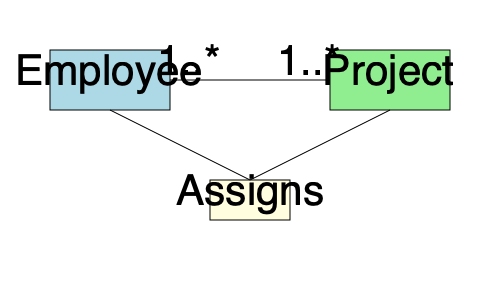Given the entity-relationship diagram above representing employees and projects in a paperless organization management system, what is the most efficient way to implement this many-to-many relationship in a relational database schema to optimize query performance and maintain data integrity? To optimize the database schema design based on the given entity-relationship diagram, we need to follow these steps:

1. Identify the entities: We have two main entities - Employee and Project.

2. Recognize the relationship: There is a many-to-many relationship between Employee and Project, represented by the "Assigns" relationship.

3. Create tables for entities:
   - Create an "Employees" table with a primary key (e.g., EmployeeID).
   - Create a "Projects" table with a primary key (e.g., ProjectID).

4. Handle the many-to-many relationship:
   - Create a junction table, often called "Assignments" or "EmployeeProjects".
   - This table should have two foreign keys: EmployeeID and ProjectID.
   - The combination of these two foreign keys should form the primary key of the junction table.

5. Optimize for query performance:
   - Add indexes on the foreign key columns in the junction table.
   - Consider adding additional columns to the junction table if needed (e.g., AssignmentDate, Role).

6. Maintain data integrity:
   - Implement referential integrity constraints on the foreign keys in the junction table.
   - Use ON DELETE and ON UPDATE actions (e.g., CASCADE, RESTRICT) as appropriate for the business rules.

The most efficient implementation is to create three tables: Employees, Projects, and a junction table (e.g., Assignments). The junction table resolves the many-to-many relationship and allows for efficient querying and maintenance of the relationship between employees and projects.
Answer: Create Employees, Projects, and Assignments (junction) tables, with Assignments having foreign keys to both Employees and Projects. 